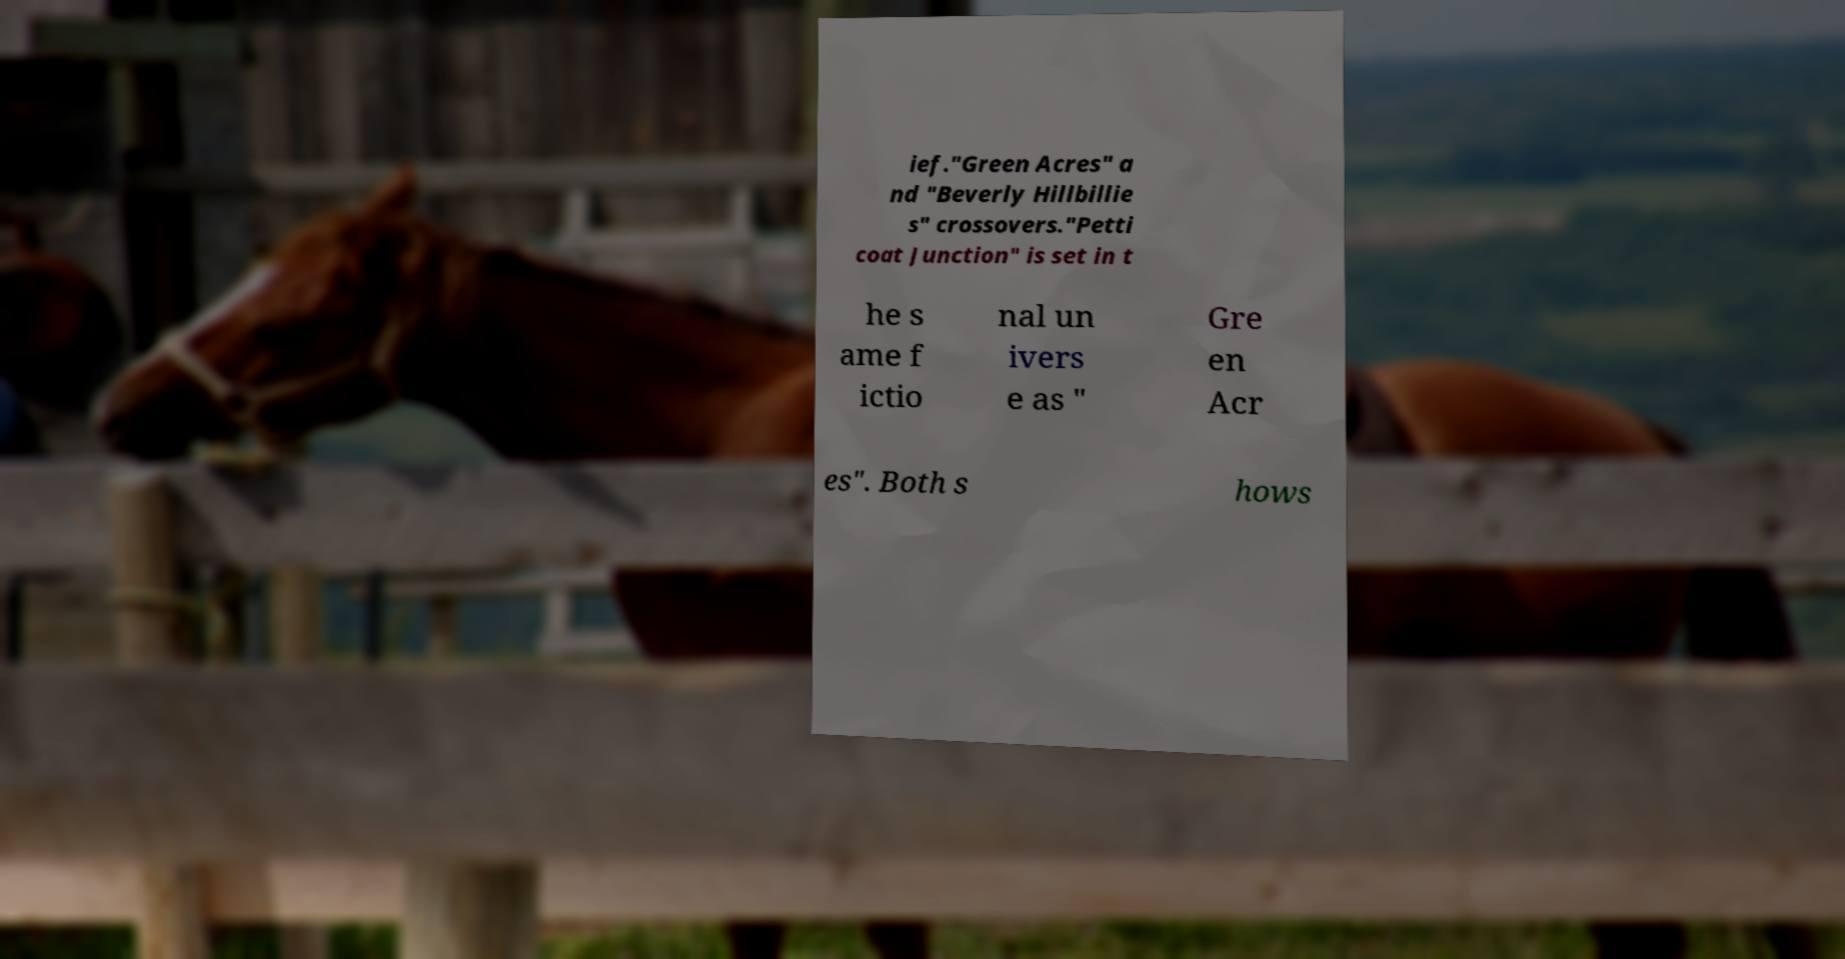There's text embedded in this image that I need extracted. Can you transcribe it verbatim? ief."Green Acres" a nd "Beverly Hillbillie s" crossovers."Petti coat Junction" is set in t he s ame f ictio nal un ivers e as " Gre en Acr es". Both s hows 